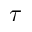Convert formula to latex. <formula><loc_0><loc_0><loc_500><loc_500>\tau</formula> 